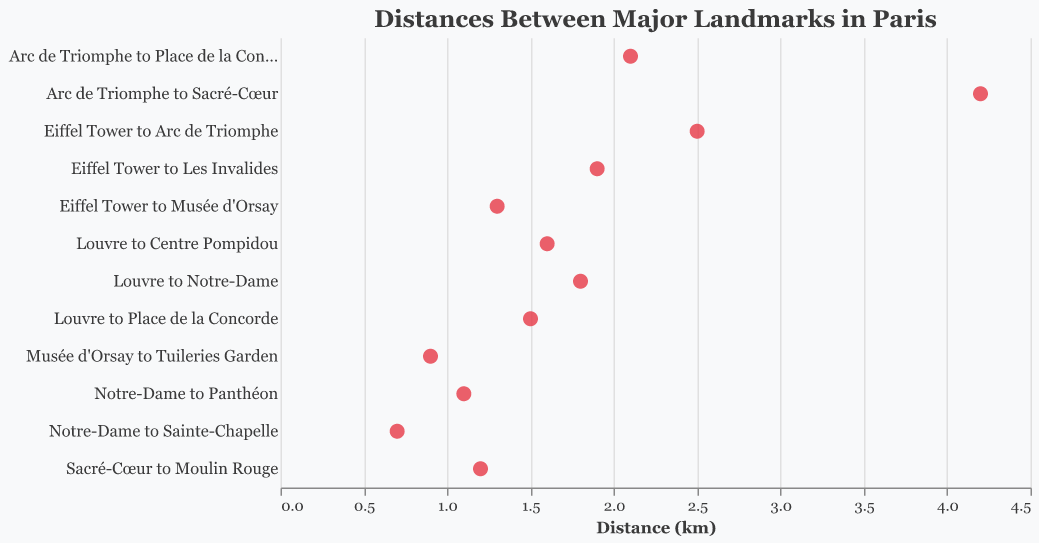What is the title of the plot? The title is located at the top of the plot and it provides context about what the data represents.
Answer: Distances Between Major Landmarks in Paris How many landmarks are represented in the plot? Each point on the y-axis represents a unique landmark pair, so by counting these points, we find the total number of landmarks represented.
Answer: 12 Which landmark pair has the shortest distance, and what is that distance? By examining the x-axis, which represents the distance in kilometers, the point closest to zero shows the shortest distance.
Answer: Notre-Dame to Sainte-Chapelle, 0.7 km Which landmark pair has the longest distance, and what is that distance? The point farthest from zero on the x-axis indicates the longest distance between landmarks.
Answer: Arc de Triomphe to Sacré-Cœur, 4.2 km What is the average distance between these landmarks? Sum all the distances and then divide by the number of landmark pairs to find the average. The sum of the distances is (2.5 + 1.8 + 4.2 + 0.7 + 1.3 + 1.5 + 2.1 + 1.2 + 1.9 + 1.1 + 0.9 + 1.6) = 20.8. Dividing by the 12 pairs gives the average distance.
Answer: 1.73 km How many landmark pairs have a distance greater than 2 km? By counting the points on the plot that are positioned beyond the 2 km mark on the x-axis, we find the number of landmark pairs with distances greater than 2 km.
Answer: 4 Which landmark pair is closest to 1 km apart? The point on the x-axis closest to 1 km indicates the landmark pair nearest to that distance.
Answer: Notre-Dame to Panthéon, 1.1 km What is the total distance if you combine the distances from Eiffel Tower to Arc de Triomphe and Louvre to Place de la Concorde? By adding the distance between these two landmark pairs: 2.5 km + 1.5 km = 4 km.
Answer: 4 km Which landmark pair has a distance exactly 1.5 km? The point on the y-axis that aligns with the 1.5 km mark on the x-axis indicates the specific landmark pair.
Answer: Louvre to Place de la Concorde Is the average distance less than or greater than 2 km? Calculate the average distance previously and compare it with 2 km. The average distance we calculated is 1.73 km. As it's less than 2 km, we answer accordingly.
Answer: Less 